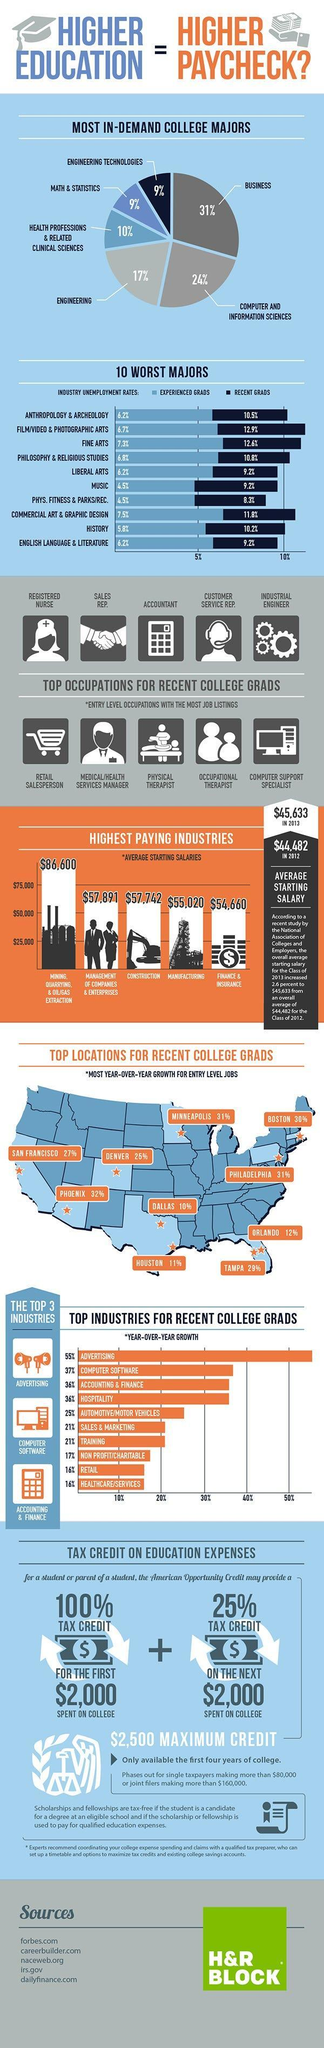What is the percentage demand in engineering majors in U.S. colleges?
Answer the question with a short phrase. 17% What is the percentage demand in Math & statistics majors in U.S. colleges? 9% What percentage is the unemployment rate for recent graduates in music industry? 9.2% What percentage of tax credit is offered for a student or parent of a student that the American opportunity credit  may provide for the first $2000 spent on college? 100% Which is the first most in-demand college major in the U.S. colleges? BUSINESS What percentage is the unemployment rate for recent graduates in commercial art & graphic design industry? 11.8% What is the average starting salary for employees working in the manufacturing field in U.S. in 2013? $55,020 What is the average starting salary for employees working in the construction field in U.S. in 2013? $57,742 What percentage is the unemployment rate for experienced graduates in fine arts industry? 7.3% Which is the second most in-demand college major in the U.S. colleges? COMPUTER AND INFORMATION SCIENCES 